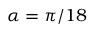Convert formula to latex. <formula><loc_0><loc_0><loc_500><loc_500>\alpha = \pi / 1 8</formula> 